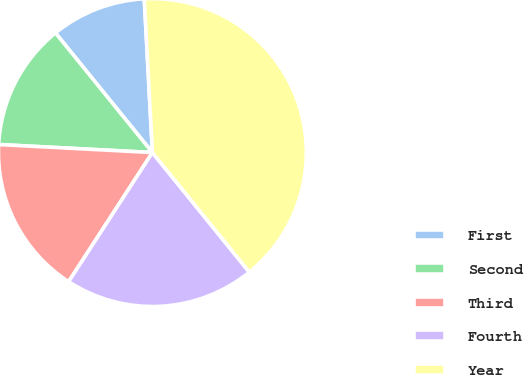<chart> <loc_0><loc_0><loc_500><loc_500><pie_chart><fcel>First<fcel>Second<fcel>Third<fcel>Fourth<fcel>Year<nl><fcel>10.0%<fcel>13.33%<fcel>16.67%<fcel>20.0%<fcel>40.0%<nl></chart> 